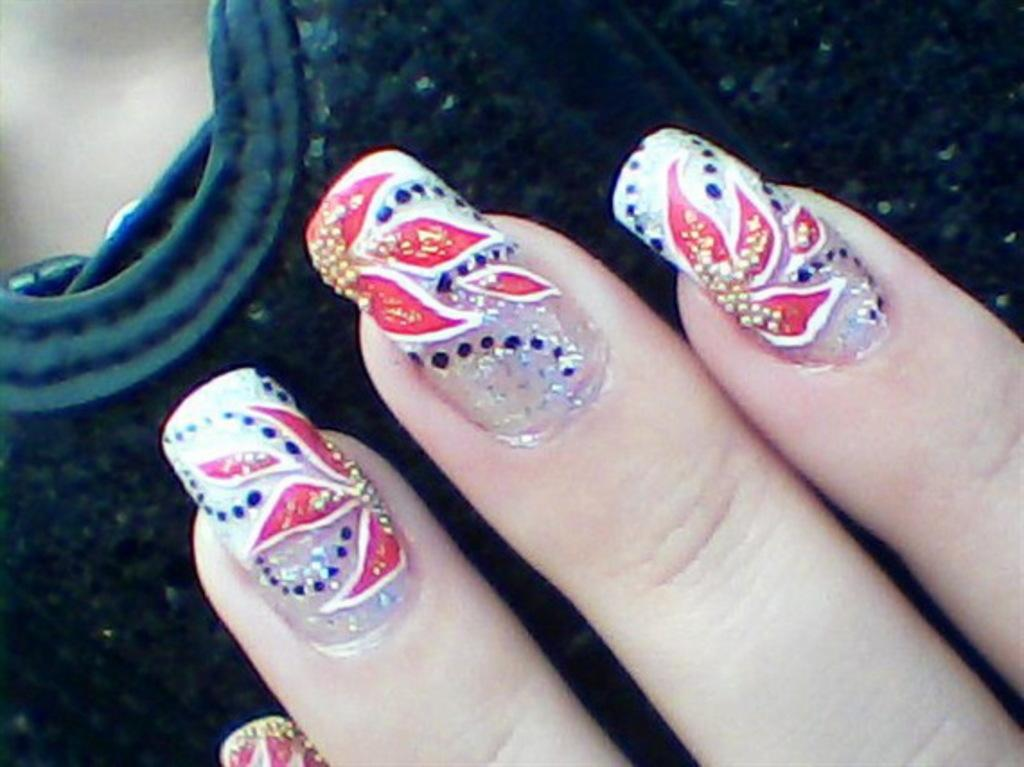What is the main subject in the center of the image? There is a dark color object in the center of the image. Can you describe any human elements in the image? The fingers of a person are visible in the image. What is a noticeable feature of the person's fingers? The person's nails have nail paint on them. How would you describe the background of the image? The background of the image is blurred. What type of silk material can be seen in the image? There is no silk material present in the image. Can you describe the trail left by the person in the image? There is no trail left by the person in the image. 